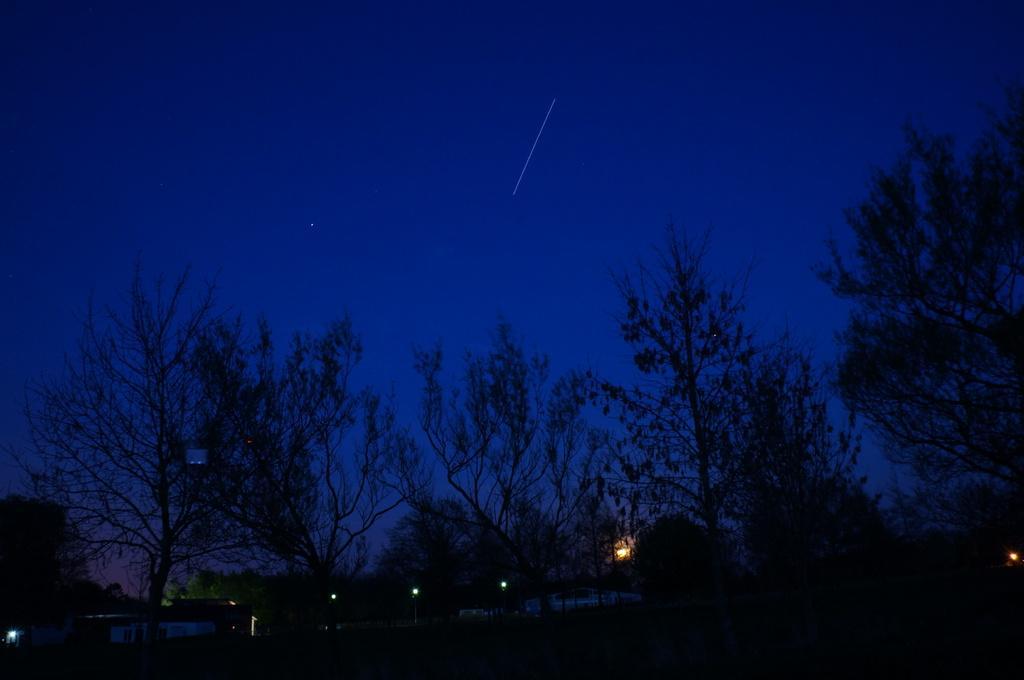Describe this image in one or two sentences. In this image there are trees and there are lights. 